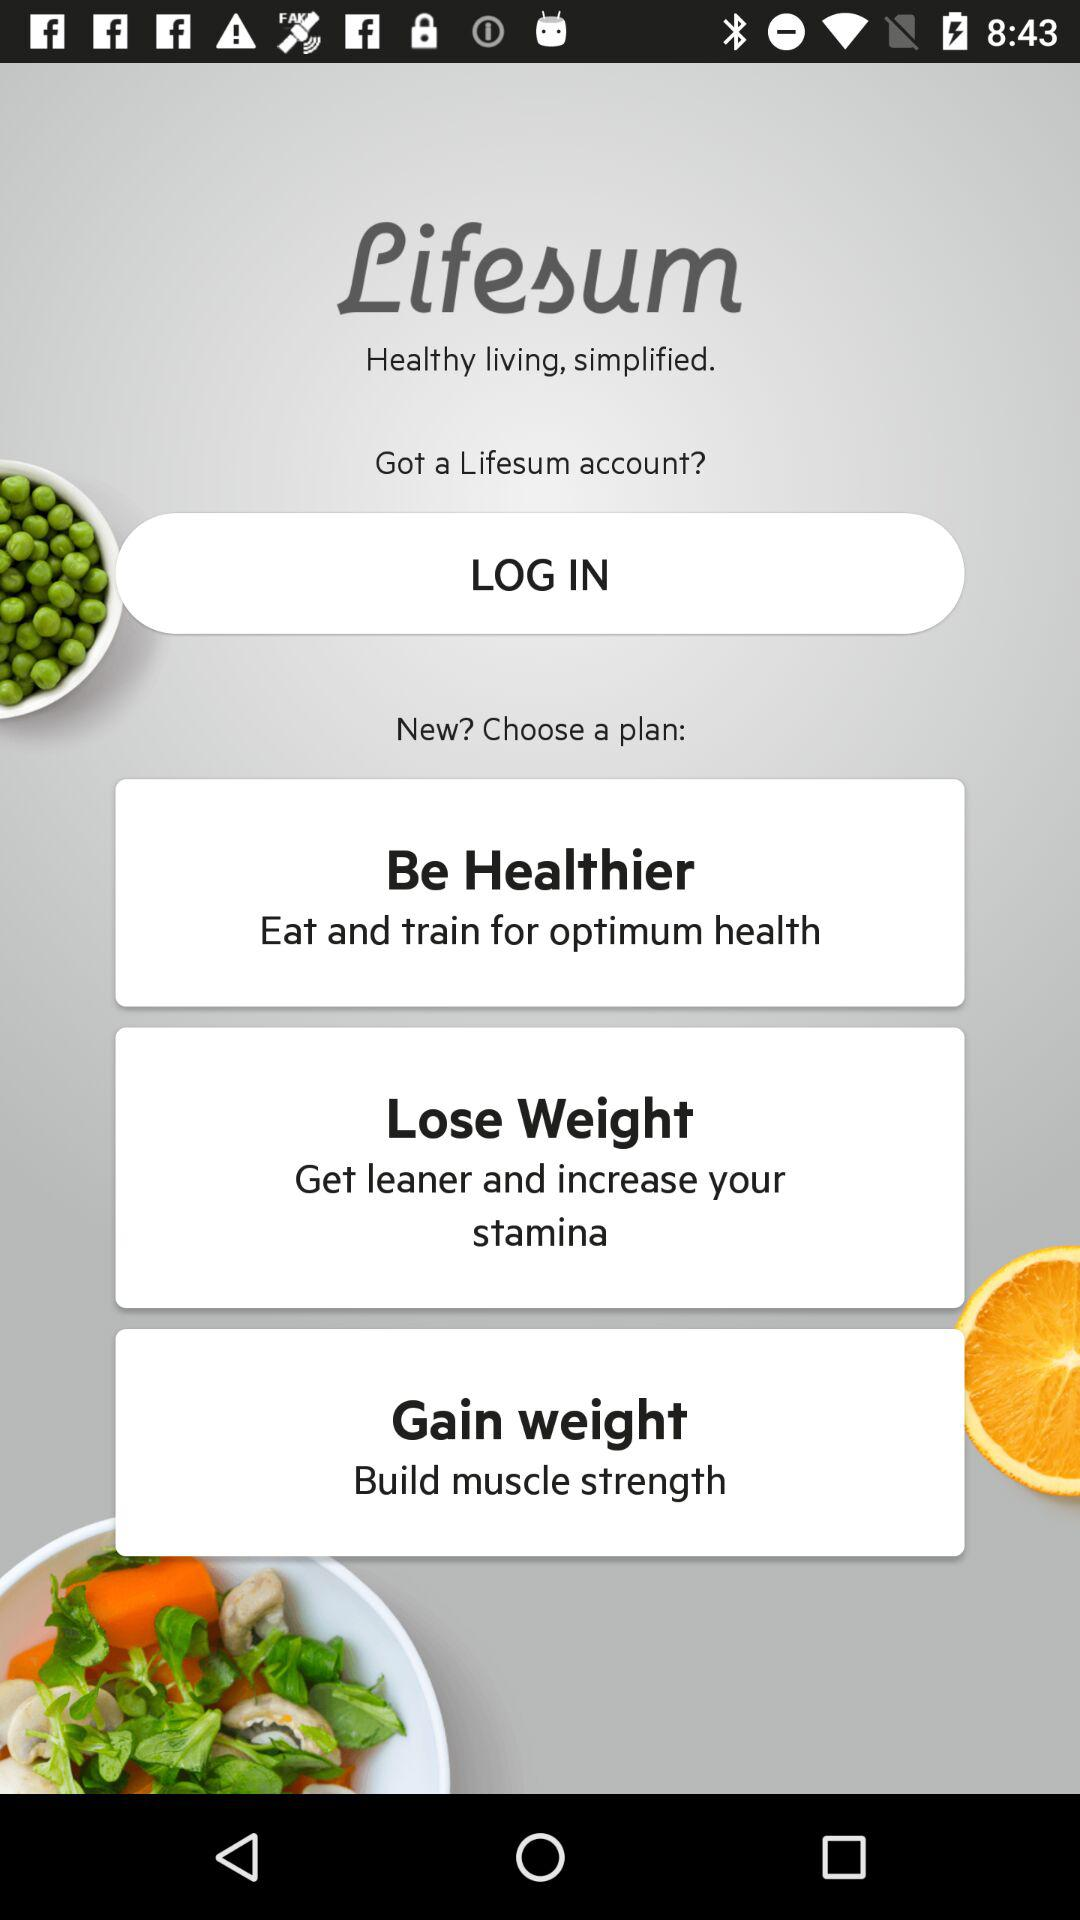What is the benefit of the plan to "lose weight"? The benefit is "Get leaner and increase your stamina". 